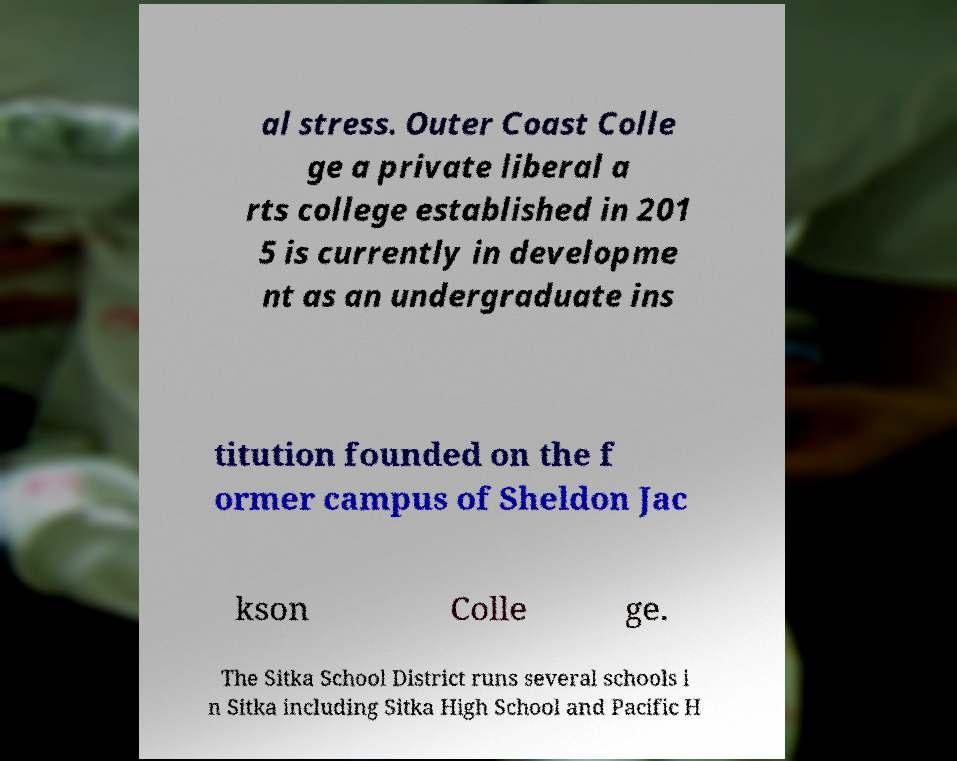There's text embedded in this image that I need extracted. Can you transcribe it verbatim? al stress. Outer Coast Colle ge a private liberal a rts college established in 201 5 is currently in developme nt as an undergraduate ins titution founded on the f ormer campus of Sheldon Jac kson Colle ge. The Sitka School District runs several schools i n Sitka including Sitka High School and Pacific H 